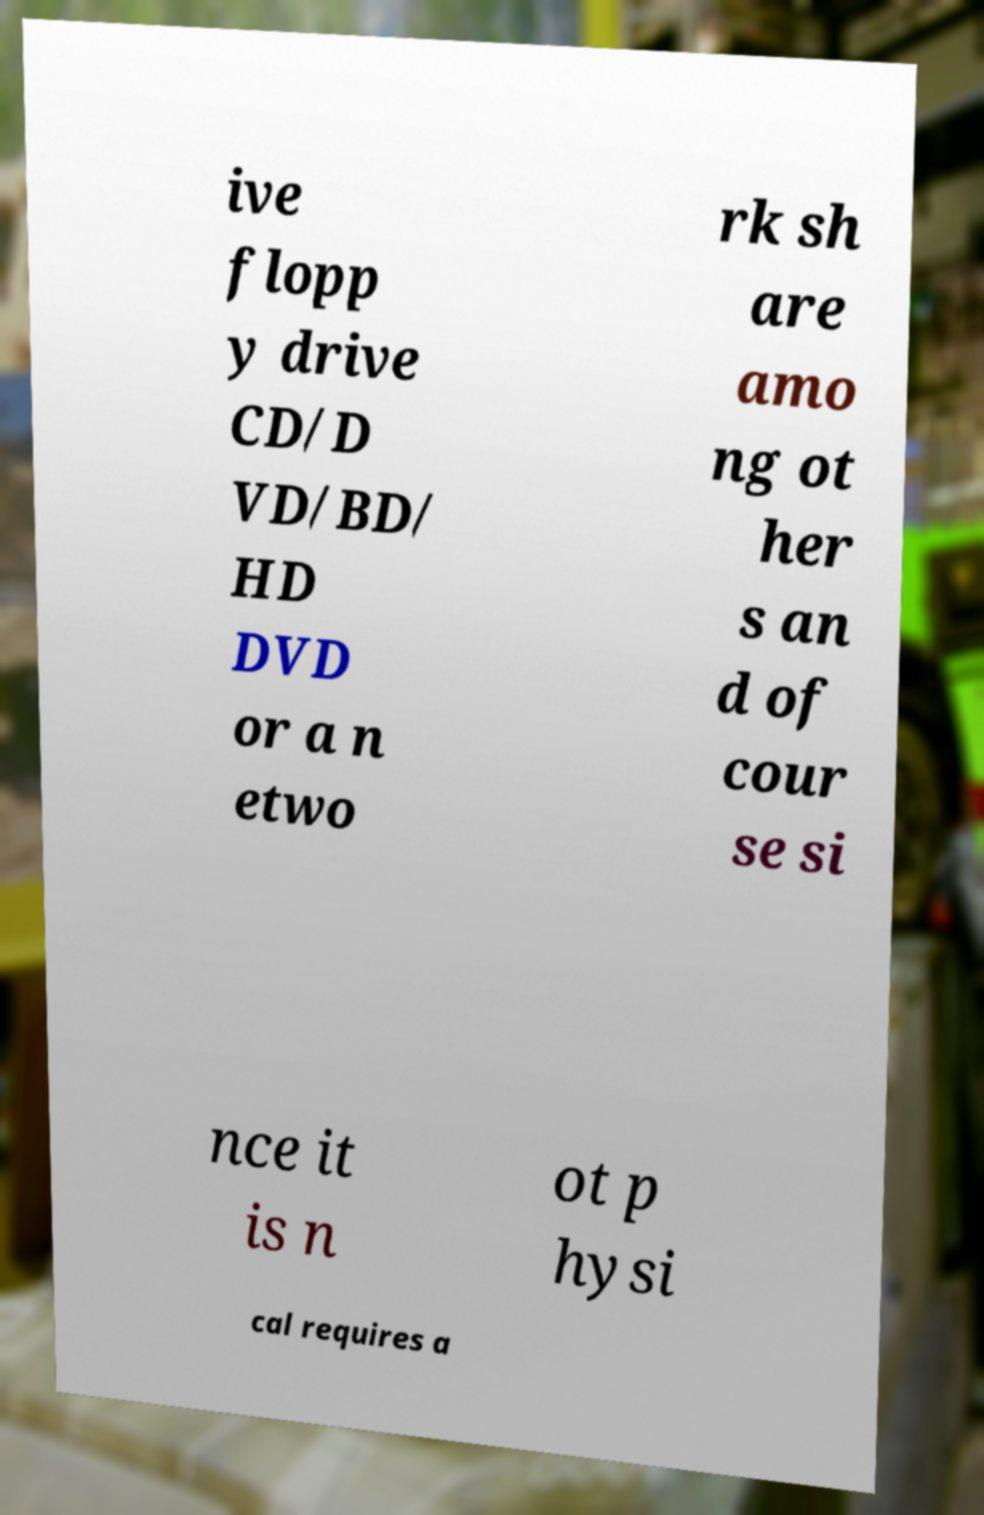Can you read and provide the text displayed in the image?This photo seems to have some interesting text. Can you extract and type it out for me? ive flopp y drive CD/D VD/BD/ HD DVD or a n etwo rk sh are amo ng ot her s an d of cour se si nce it is n ot p hysi cal requires a 